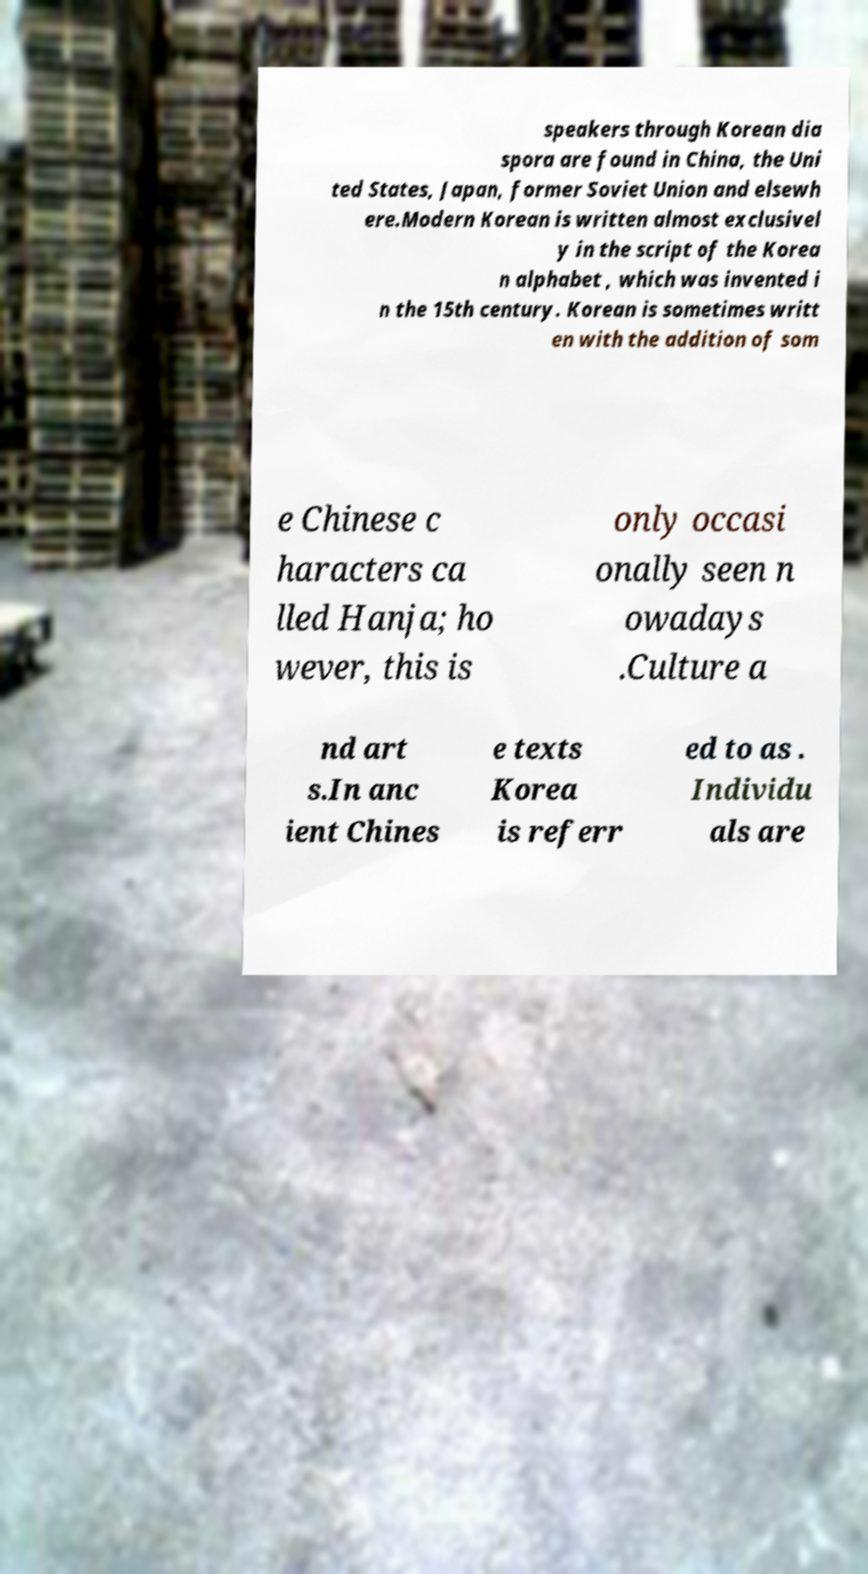Can you read and provide the text displayed in the image?This photo seems to have some interesting text. Can you extract and type it out for me? speakers through Korean dia spora are found in China, the Uni ted States, Japan, former Soviet Union and elsewh ere.Modern Korean is written almost exclusivel y in the script of the Korea n alphabet , which was invented i n the 15th century. Korean is sometimes writt en with the addition of som e Chinese c haracters ca lled Hanja; ho wever, this is only occasi onally seen n owadays .Culture a nd art s.In anc ient Chines e texts Korea is referr ed to as . Individu als are 